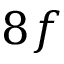Convert formula to latex. <formula><loc_0><loc_0><loc_500><loc_500>8 f</formula> 